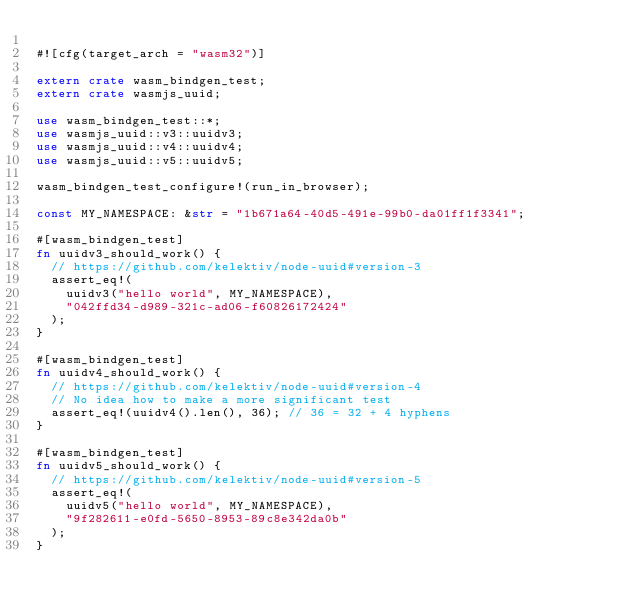Convert code to text. <code><loc_0><loc_0><loc_500><loc_500><_Rust_>
#![cfg(target_arch = "wasm32")]

extern crate wasm_bindgen_test;
extern crate wasmjs_uuid;

use wasm_bindgen_test::*;
use wasmjs_uuid::v3::uuidv3;
use wasmjs_uuid::v4::uuidv4;
use wasmjs_uuid::v5::uuidv5;

wasm_bindgen_test_configure!(run_in_browser);

const MY_NAMESPACE: &str = "1b671a64-40d5-491e-99b0-da01ff1f3341";

#[wasm_bindgen_test]
fn uuidv3_should_work() {
	// https://github.com/kelektiv/node-uuid#version-3
	assert_eq!(
		uuidv3("hello world", MY_NAMESPACE),
		"042ffd34-d989-321c-ad06-f60826172424"
	);
}

#[wasm_bindgen_test]
fn uuidv4_should_work() {
	// https://github.com/kelektiv/node-uuid#version-4
	// No idea how to make a more significant test
	assert_eq!(uuidv4().len(), 36); // 36 = 32 + 4 hyphens
}

#[wasm_bindgen_test]
fn uuidv5_should_work() {
	// https://github.com/kelektiv/node-uuid#version-5
	assert_eq!(
		uuidv5("hello world", MY_NAMESPACE),
		"9f282611-e0fd-5650-8953-89c8e342da0b"
	);
}
</code> 